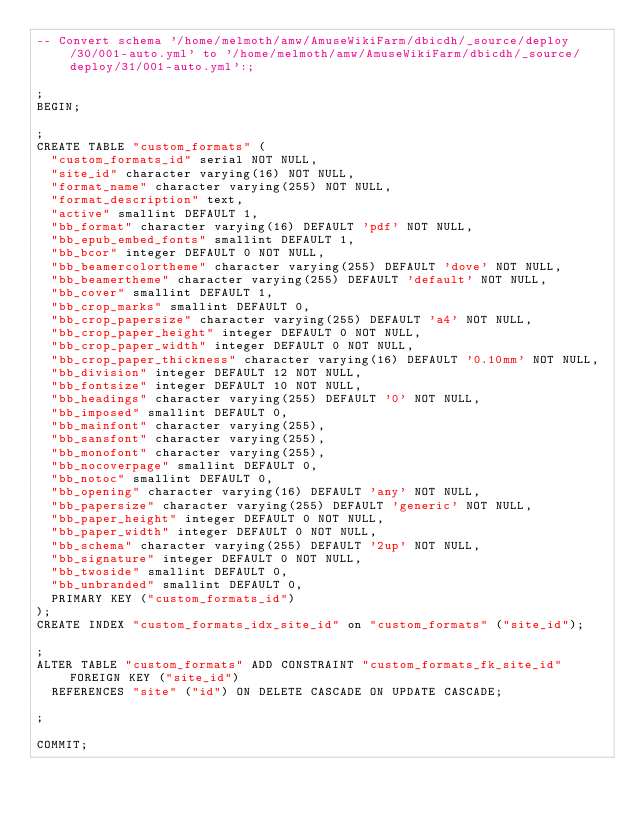Convert code to text. <code><loc_0><loc_0><loc_500><loc_500><_SQL_>-- Convert schema '/home/melmoth/amw/AmuseWikiFarm/dbicdh/_source/deploy/30/001-auto.yml' to '/home/melmoth/amw/AmuseWikiFarm/dbicdh/_source/deploy/31/001-auto.yml':;

;
BEGIN;

;
CREATE TABLE "custom_formats" (
  "custom_formats_id" serial NOT NULL,
  "site_id" character varying(16) NOT NULL,
  "format_name" character varying(255) NOT NULL,
  "format_description" text,
  "active" smallint DEFAULT 1,
  "bb_format" character varying(16) DEFAULT 'pdf' NOT NULL,
  "bb_epub_embed_fonts" smallint DEFAULT 1,
  "bb_bcor" integer DEFAULT 0 NOT NULL,
  "bb_beamercolortheme" character varying(255) DEFAULT 'dove' NOT NULL,
  "bb_beamertheme" character varying(255) DEFAULT 'default' NOT NULL,
  "bb_cover" smallint DEFAULT 1,
  "bb_crop_marks" smallint DEFAULT 0,
  "bb_crop_papersize" character varying(255) DEFAULT 'a4' NOT NULL,
  "bb_crop_paper_height" integer DEFAULT 0 NOT NULL,
  "bb_crop_paper_width" integer DEFAULT 0 NOT NULL,
  "bb_crop_paper_thickness" character varying(16) DEFAULT '0.10mm' NOT NULL,
  "bb_division" integer DEFAULT 12 NOT NULL,
  "bb_fontsize" integer DEFAULT 10 NOT NULL,
  "bb_headings" character varying(255) DEFAULT '0' NOT NULL,
  "bb_imposed" smallint DEFAULT 0,
  "bb_mainfont" character varying(255),
  "bb_sansfont" character varying(255),
  "bb_monofont" character varying(255),
  "bb_nocoverpage" smallint DEFAULT 0,
  "bb_notoc" smallint DEFAULT 0,
  "bb_opening" character varying(16) DEFAULT 'any' NOT NULL,
  "bb_papersize" character varying(255) DEFAULT 'generic' NOT NULL,
  "bb_paper_height" integer DEFAULT 0 NOT NULL,
  "bb_paper_width" integer DEFAULT 0 NOT NULL,
  "bb_schema" character varying(255) DEFAULT '2up' NOT NULL,
  "bb_signature" integer DEFAULT 0 NOT NULL,
  "bb_twoside" smallint DEFAULT 0,
  "bb_unbranded" smallint DEFAULT 0,
  PRIMARY KEY ("custom_formats_id")
);
CREATE INDEX "custom_formats_idx_site_id" on "custom_formats" ("site_id");

;
ALTER TABLE "custom_formats" ADD CONSTRAINT "custom_formats_fk_site_id" FOREIGN KEY ("site_id")
  REFERENCES "site" ("id") ON DELETE CASCADE ON UPDATE CASCADE;

;

COMMIT;

</code> 